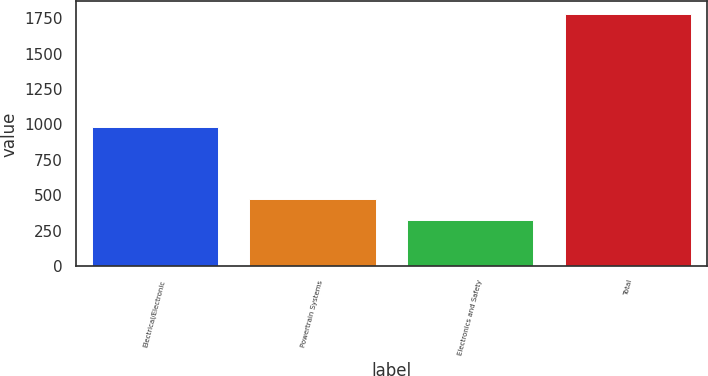Convert chart to OTSL. <chart><loc_0><loc_0><loc_500><loc_500><bar_chart><fcel>Electrical/Electronic<fcel>Powertrain Systems<fcel>Electronics and Safety<fcel>Total<nl><fcel>982<fcel>472.2<fcel>327<fcel>1779<nl></chart> 